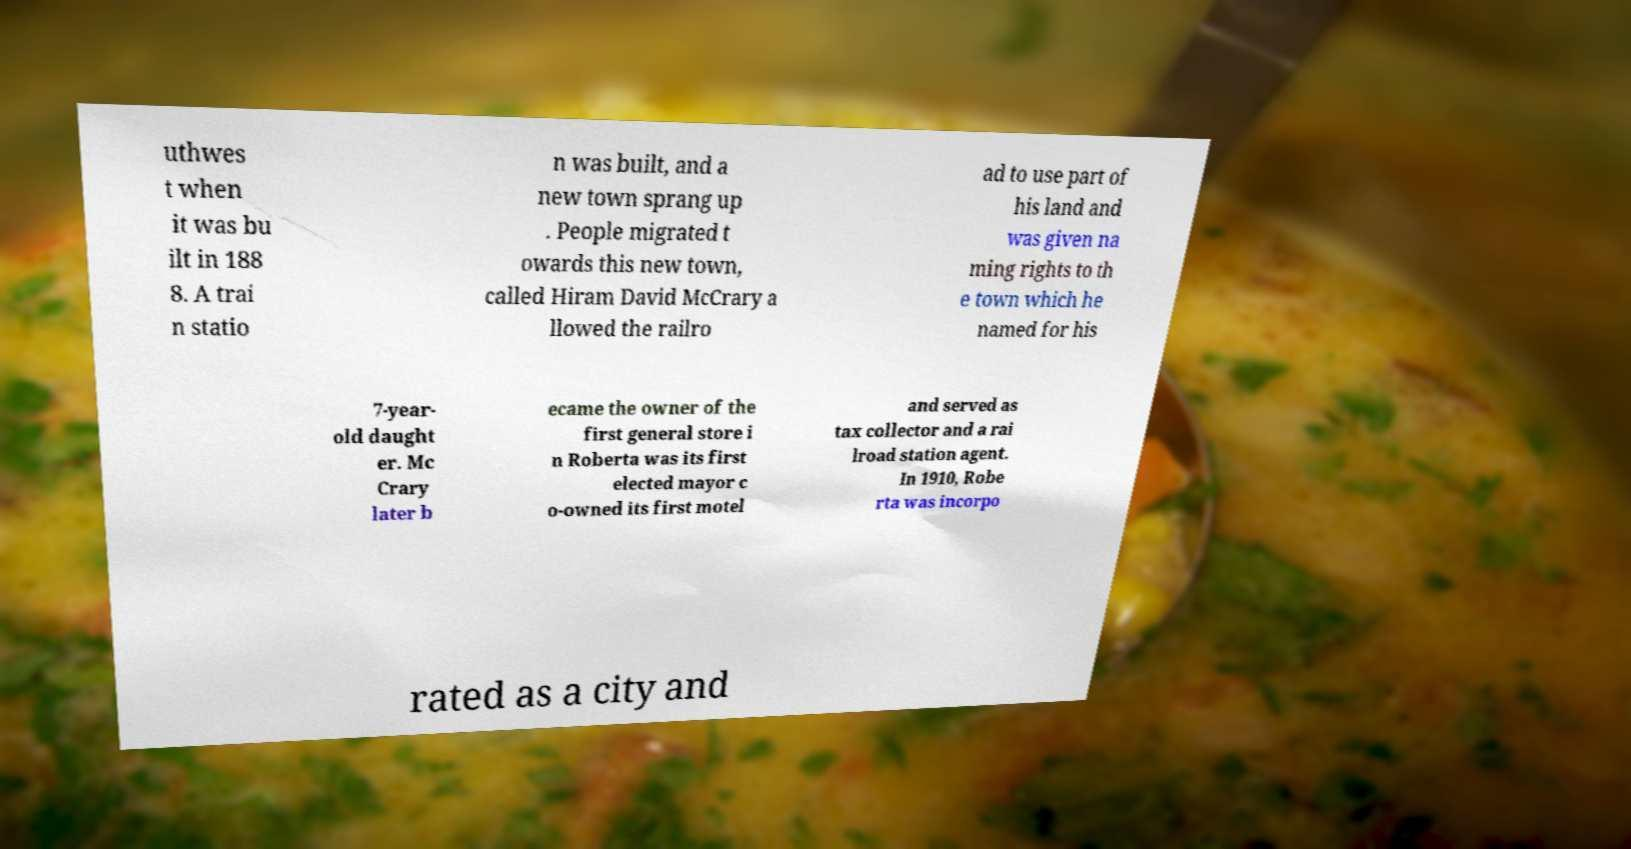What messages or text are displayed in this image? I need them in a readable, typed format. uthwes t when it was bu ilt in 188 8. A trai n statio n was built, and a new town sprang up . People migrated t owards this new town, called Hiram David McCrary a llowed the railro ad to use part of his land and was given na ming rights to th e town which he named for his 7-year- old daught er. Mc Crary later b ecame the owner of the first general store i n Roberta was its first elected mayor c o-owned its first motel and served as tax collector and a rai lroad station agent. In 1910, Robe rta was incorpo rated as a city and 